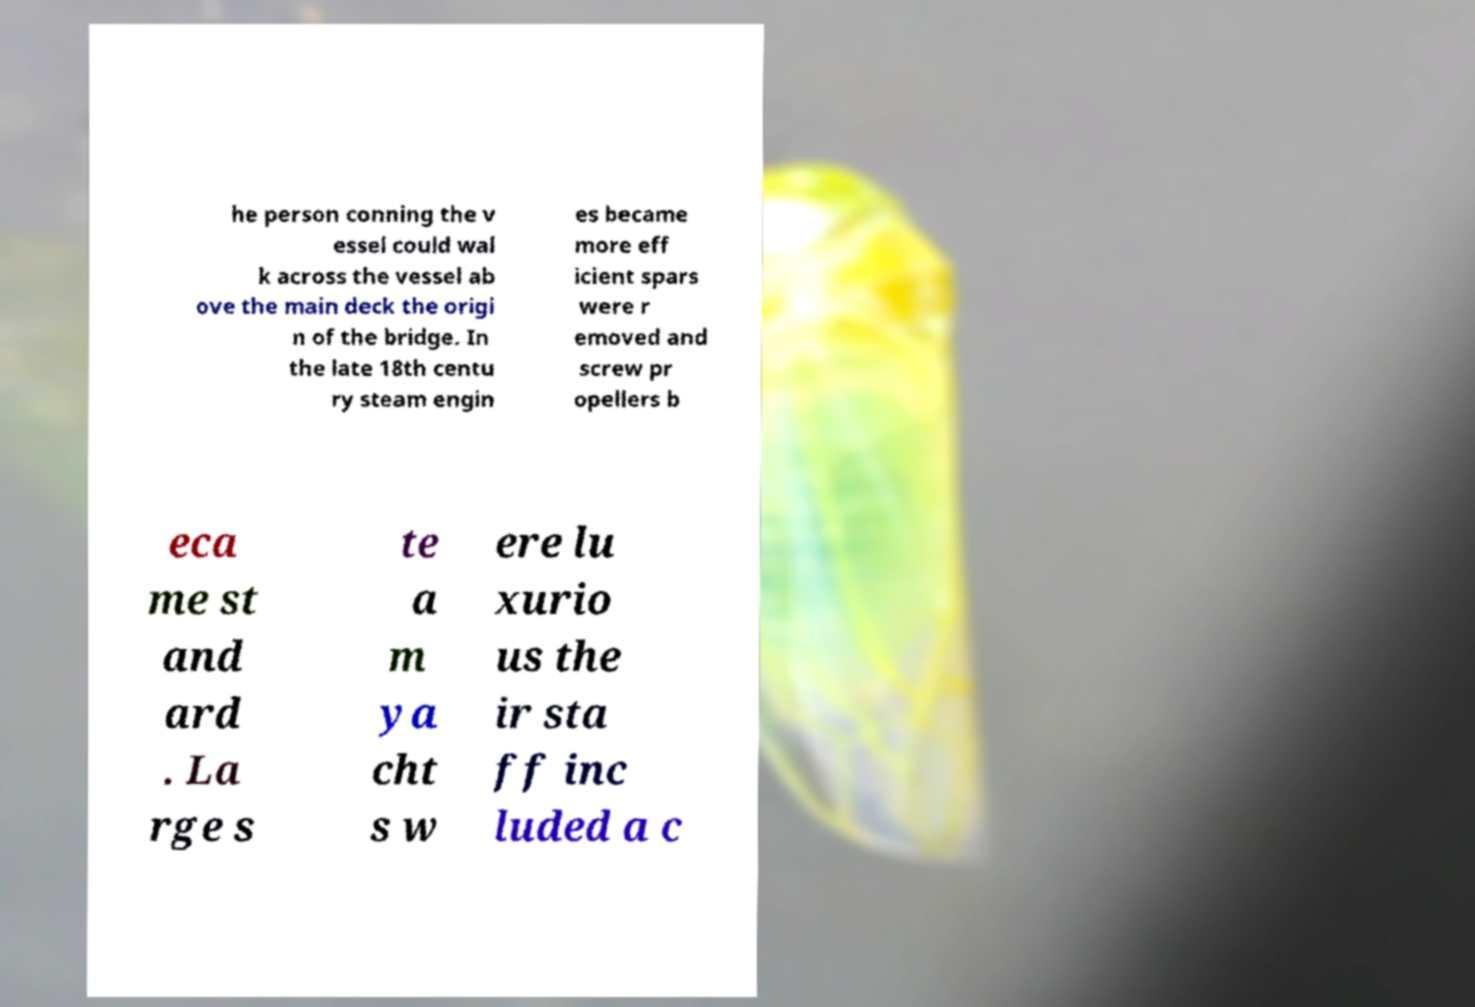Could you extract and type out the text from this image? he person conning the v essel could wal k across the vessel ab ove the main deck the origi n of the bridge. In the late 18th centu ry steam engin es became more eff icient spars were r emoved and screw pr opellers b eca me st and ard . La rge s te a m ya cht s w ere lu xurio us the ir sta ff inc luded a c 